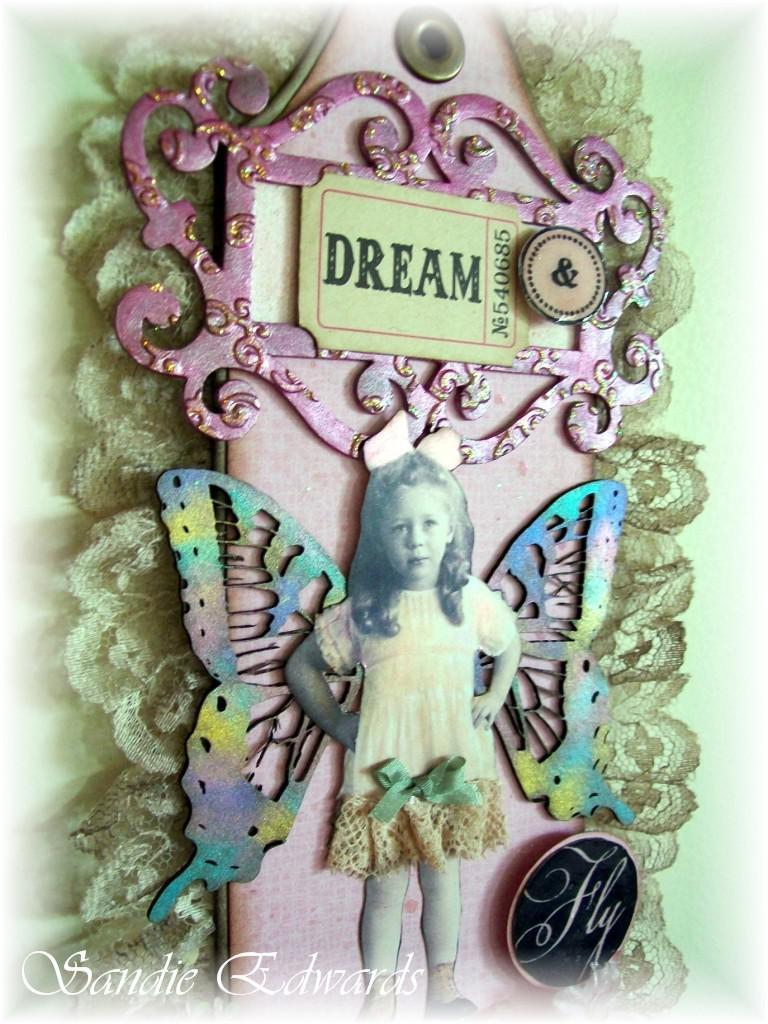<image>
Describe the image concisely. A piece of artwork that has a girl with butterfly wings says "Dream". 